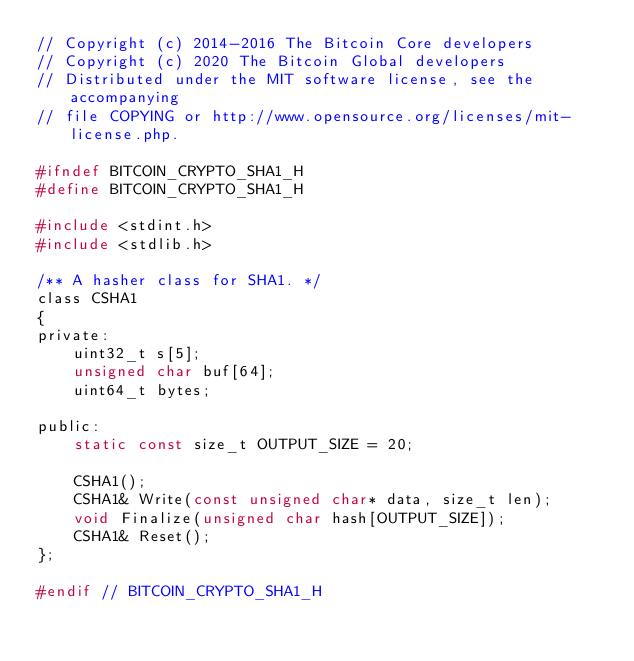Convert code to text. <code><loc_0><loc_0><loc_500><loc_500><_C_>// Copyright (c) 2014-2016 The Bitcoin Core developers
// Copyright (c) 2020 The Bitcoin Global developers
// Distributed under the MIT software license, see the accompanying
// file COPYING or http://www.opensource.org/licenses/mit-license.php.

#ifndef BITCOIN_CRYPTO_SHA1_H
#define BITCOIN_CRYPTO_SHA1_H

#include <stdint.h>
#include <stdlib.h>

/** A hasher class for SHA1. */
class CSHA1
{
private:
    uint32_t s[5];
    unsigned char buf[64];
    uint64_t bytes;

public:
    static const size_t OUTPUT_SIZE = 20;

    CSHA1();
    CSHA1& Write(const unsigned char* data, size_t len);
    void Finalize(unsigned char hash[OUTPUT_SIZE]);
    CSHA1& Reset();
};

#endif // BITCOIN_CRYPTO_SHA1_H
</code> 